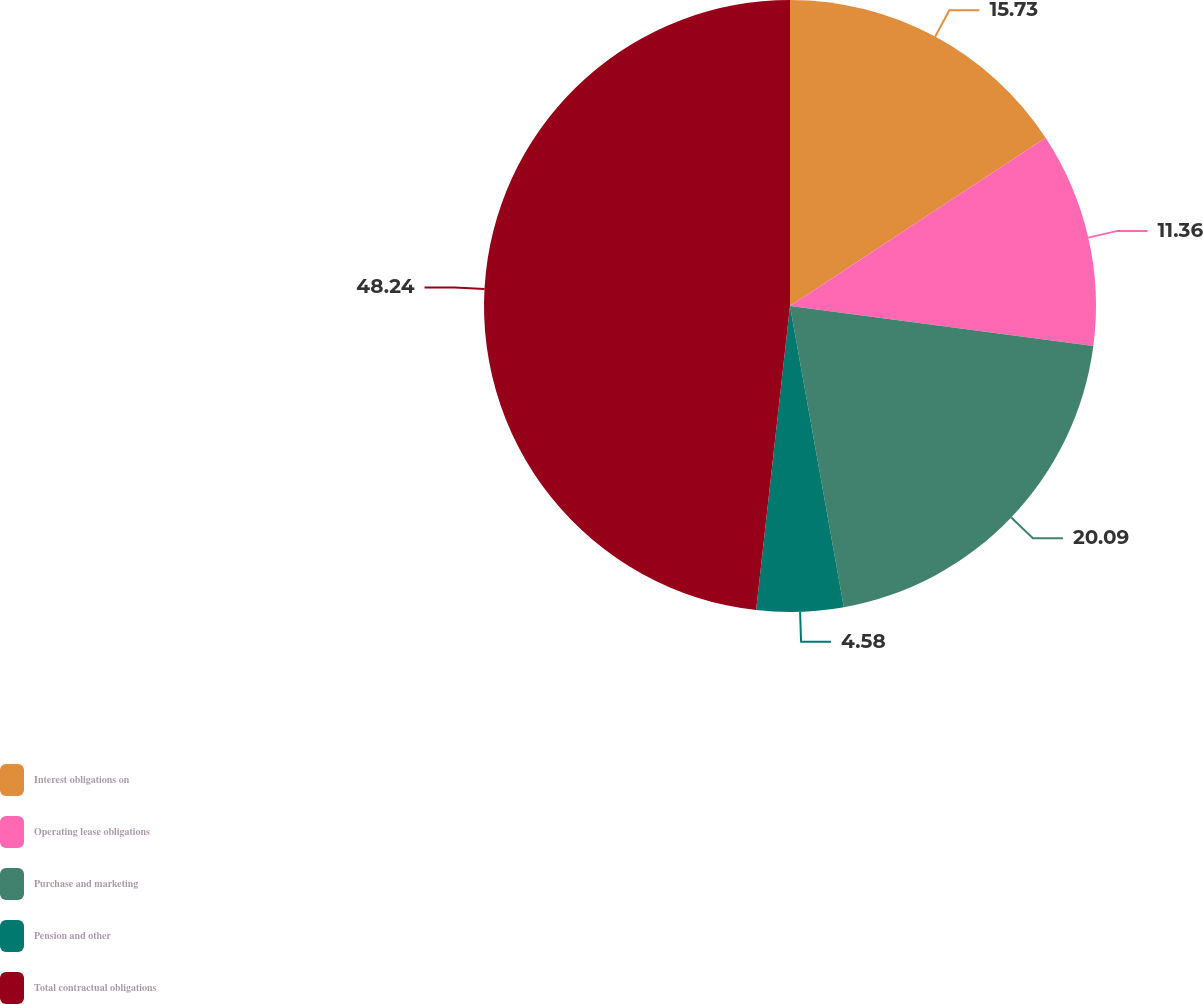Convert chart to OTSL. <chart><loc_0><loc_0><loc_500><loc_500><pie_chart><fcel>Interest obligations on<fcel>Operating lease obligations<fcel>Purchase and marketing<fcel>Pension and other<fcel>Total contractual obligations<nl><fcel>15.73%<fcel>11.36%<fcel>20.09%<fcel>4.58%<fcel>48.23%<nl></chart> 